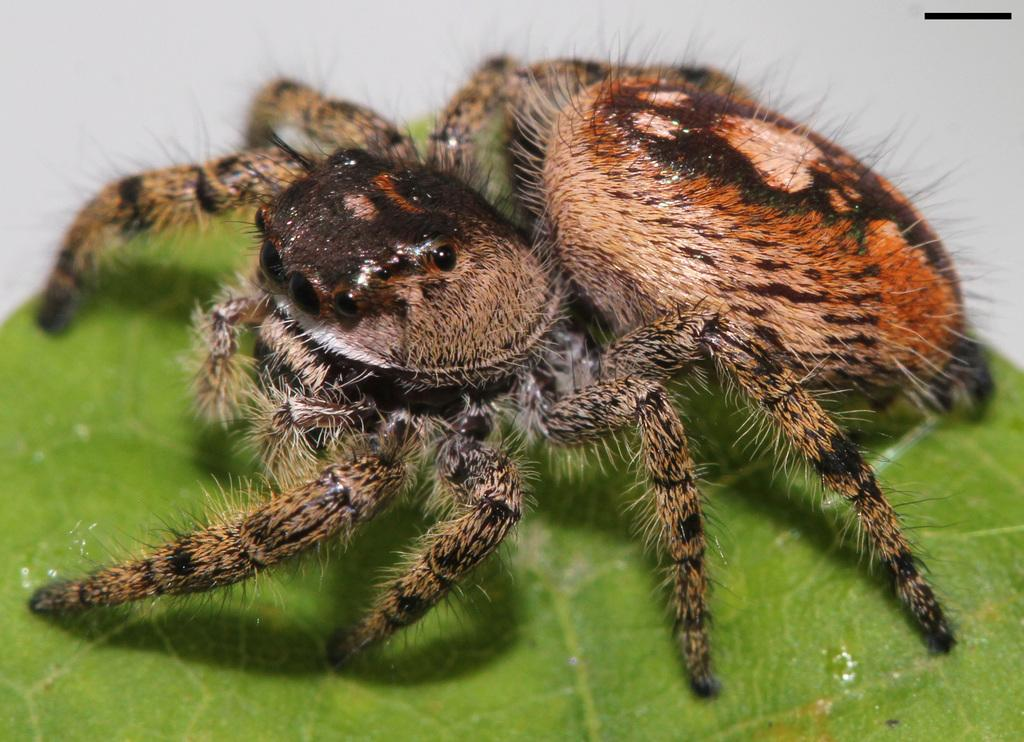What type of creature can be seen in the image? There is an insect in the image. Where is the insect located? The insect is present on a leaf. What type of protest is the carpenter organizing in the image? There is no carpenter or protest present in the image; it features an insect on a leaf. Who is the creator of the insect in the image? The image does not provide information about the creator of the insect, as it is a photograph of a real insect. 